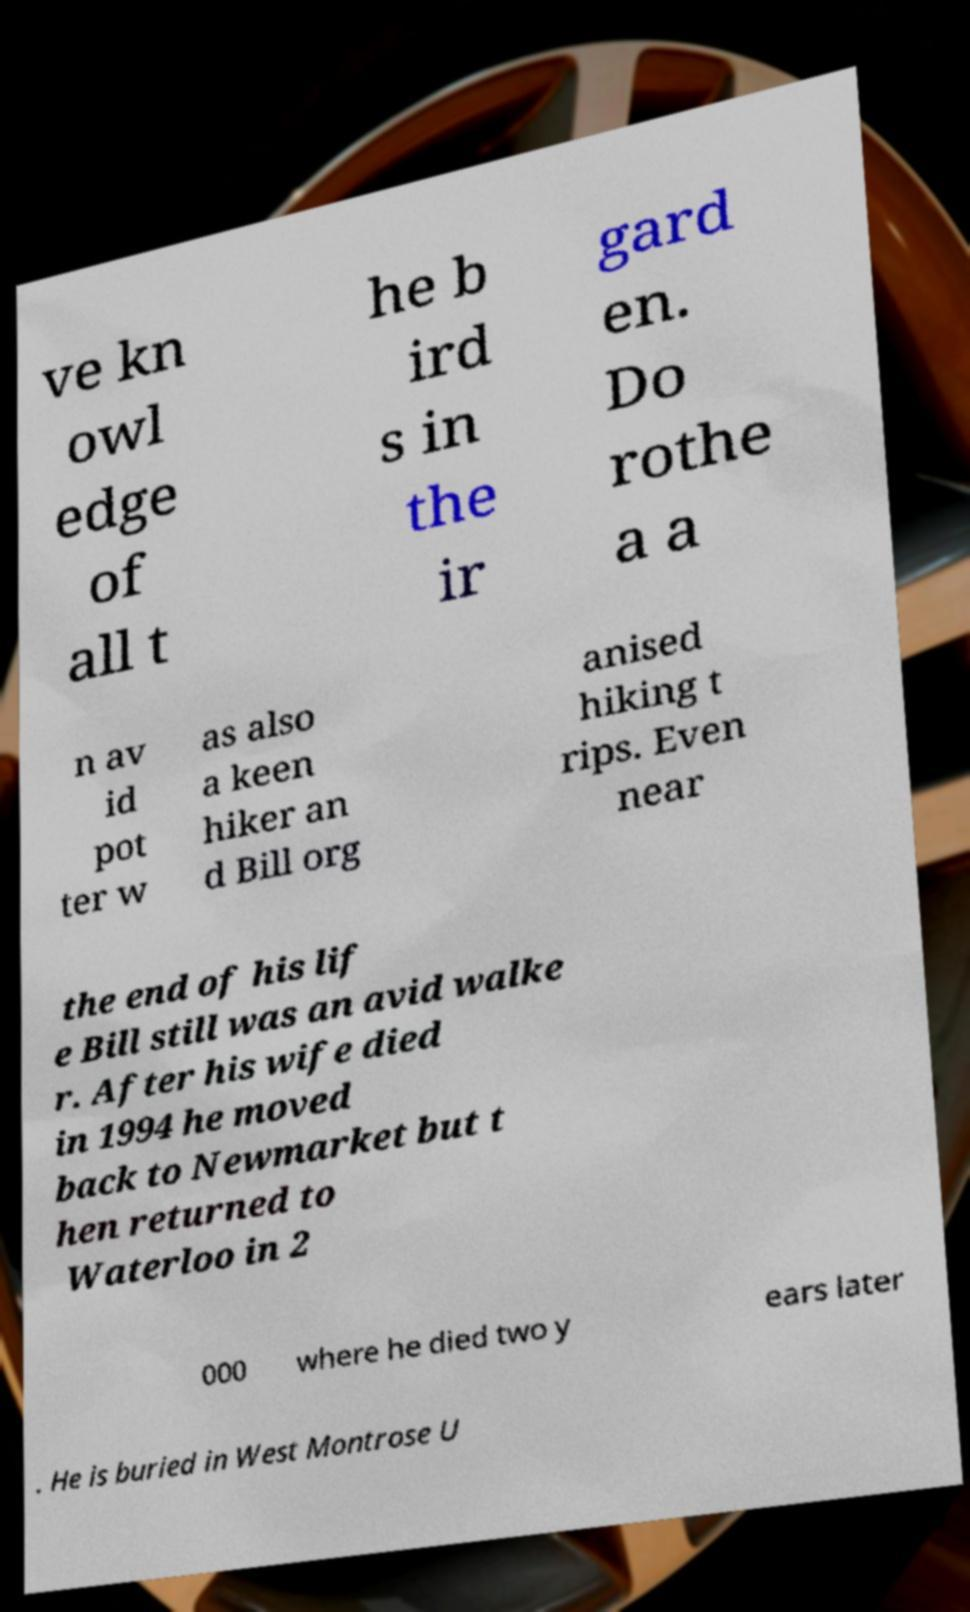Please identify and transcribe the text found in this image. ve kn owl edge of all t he b ird s in the ir gard en. Do rothe a a n av id pot ter w as also a keen hiker an d Bill org anised hiking t rips. Even near the end of his lif e Bill still was an avid walke r. After his wife died in 1994 he moved back to Newmarket but t hen returned to Waterloo in 2 000 where he died two y ears later . He is buried in West Montrose U 